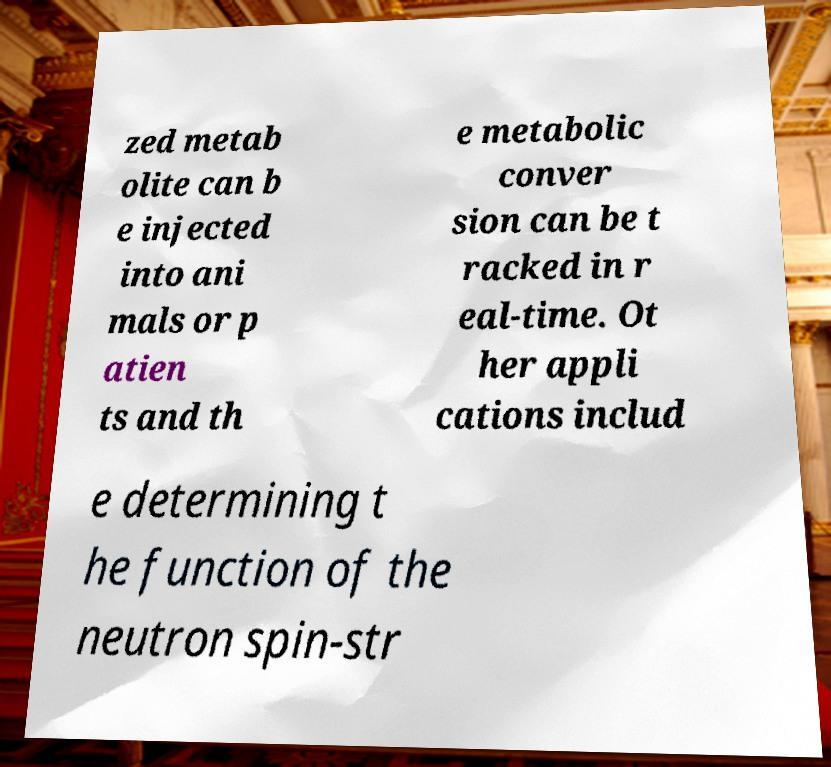Please read and relay the text visible in this image. What does it say? zed metab olite can b e injected into ani mals or p atien ts and th e metabolic conver sion can be t racked in r eal-time. Ot her appli cations includ e determining t he function of the neutron spin-str 